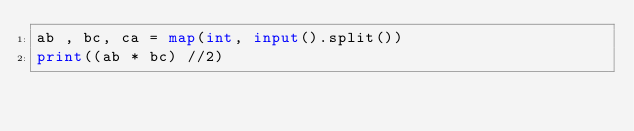<code> <loc_0><loc_0><loc_500><loc_500><_Python_>ab , bc, ca = map(int, input().split())
print((ab * bc) //2)</code> 